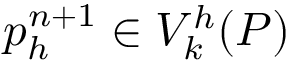<formula> <loc_0><loc_0><loc_500><loc_500>p _ { h } ^ { n + 1 } \in V _ { k } ^ { h } ( { P } )</formula> 